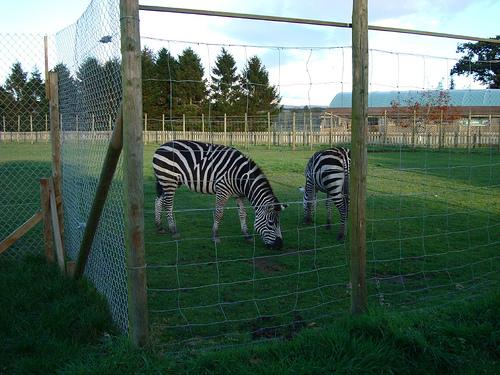This is photo taken in the zoo?
Keep it brief. Yes. Are these Zebra wild?
Write a very short answer. No. Are these zebras eating grass?
Keep it brief. Yes. 